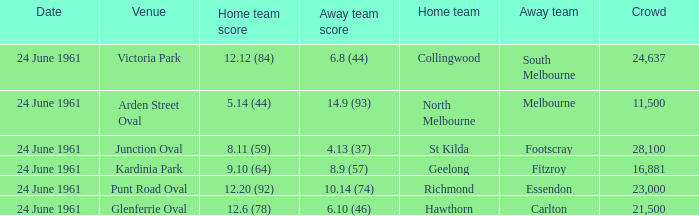Who was the home team that scored 12.6 (78)? Hawthorn. 